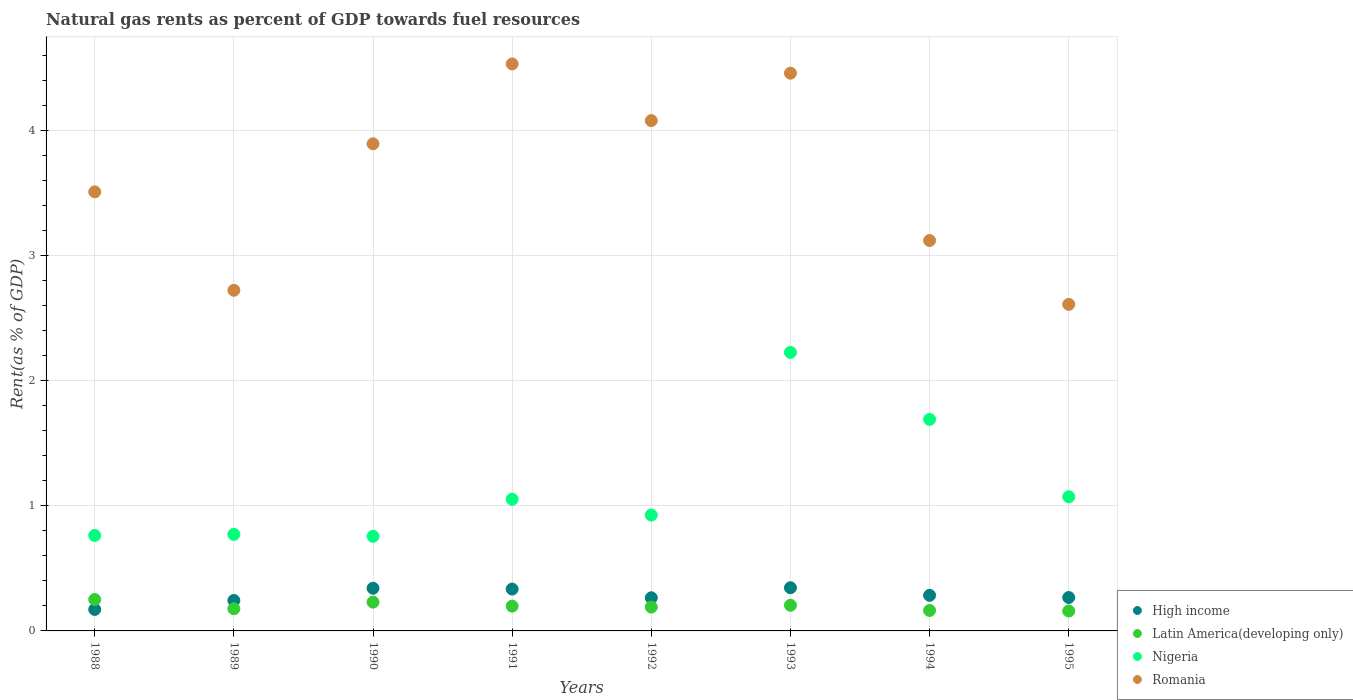How many different coloured dotlines are there?
Give a very brief answer. 4. Is the number of dotlines equal to the number of legend labels?
Ensure brevity in your answer.  Yes. What is the matural gas rent in Latin America(developing only) in 1992?
Offer a very short reply. 0.19. Across all years, what is the maximum matural gas rent in Nigeria?
Give a very brief answer. 2.23. Across all years, what is the minimum matural gas rent in Nigeria?
Your response must be concise. 0.76. In which year was the matural gas rent in Nigeria maximum?
Keep it short and to the point. 1993. In which year was the matural gas rent in Latin America(developing only) minimum?
Offer a terse response. 1995. What is the total matural gas rent in Romania in the graph?
Your answer should be compact. 28.93. What is the difference between the matural gas rent in Latin America(developing only) in 1990 and that in 1995?
Provide a short and direct response. 0.07. What is the difference between the matural gas rent in High income in 1991 and the matural gas rent in Latin America(developing only) in 1992?
Offer a very short reply. 0.14. What is the average matural gas rent in Romania per year?
Provide a short and direct response. 3.62. In the year 1990, what is the difference between the matural gas rent in Latin America(developing only) and matural gas rent in Nigeria?
Offer a terse response. -0.53. In how many years, is the matural gas rent in High income greater than 2 %?
Ensure brevity in your answer.  0. What is the ratio of the matural gas rent in Latin America(developing only) in 1991 to that in 1992?
Ensure brevity in your answer.  1.04. What is the difference between the highest and the second highest matural gas rent in Latin America(developing only)?
Offer a terse response. 0.02. What is the difference between the highest and the lowest matural gas rent in Nigeria?
Provide a short and direct response. 1.47. In how many years, is the matural gas rent in Latin America(developing only) greater than the average matural gas rent in Latin America(developing only) taken over all years?
Ensure brevity in your answer.  4. Is it the case that in every year, the sum of the matural gas rent in Latin America(developing only) and matural gas rent in Nigeria  is greater than the sum of matural gas rent in Romania and matural gas rent in High income?
Offer a very short reply. No. Is it the case that in every year, the sum of the matural gas rent in High income and matural gas rent in Nigeria  is greater than the matural gas rent in Romania?
Give a very brief answer. No. Does the matural gas rent in Romania monotonically increase over the years?
Make the answer very short. No. Is the matural gas rent in Nigeria strictly greater than the matural gas rent in High income over the years?
Provide a succinct answer. Yes. How many years are there in the graph?
Your answer should be compact. 8. What is the difference between two consecutive major ticks on the Y-axis?
Offer a very short reply. 1. Where does the legend appear in the graph?
Ensure brevity in your answer.  Bottom right. How many legend labels are there?
Your answer should be very brief. 4. What is the title of the graph?
Provide a succinct answer. Natural gas rents as percent of GDP towards fuel resources. What is the label or title of the X-axis?
Your answer should be compact. Years. What is the label or title of the Y-axis?
Provide a short and direct response. Rent(as % of GDP). What is the Rent(as % of GDP) of High income in 1988?
Ensure brevity in your answer.  0.17. What is the Rent(as % of GDP) of Latin America(developing only) in 1988?
Provide a short and direct response. 0.25. What is the Rent(as % of GDP) of Nigeria in 1988?
Give a very brief answer. 0.76. What is the Rent(as % of GDP) in Romania in 1988?
Ensure brevity in your answer.  3.51. What is the Rent(as % of GDP) in High income in 1989?
Offer a very short reply. 0.24. What is the Rent(as % of GDP) in Latin America(developing only) in 1989?
Offer a very short reply. 0.18. What is the Rent(as % of GDP) of Nigeria in 1989?
Make the answer very short. 0.77. What is the Rent(as % of GDP) of Romania in 1989?
Make the answer very short. 2.72. What is the Rent(as % of GDP) of High income in 1990?
Give a very brief answer. 0.34. What is the Rent(as % of GDP) in Latin America(developing only) in 1990?
Offer a very short reply. 0.23. What is the Rent(as % of GDP) of Nigeria in 1990?
Offer a terse response. 0.76. What is the Rent(as % of GDP) in Romania in 1990?
Give a very brief answer. 3.89. What is the Rent(as % of GDP) of High income in 1991?
Offer a terse response. 0.33. What is the Rent(as % of GDP) of Latin America(developing only) in 1991?
Your answer should be very brief. 0.2. What is the Rent(as % of GDP) in Nigeria in 1991?
Your answer should be very brief. 1.05. What is the Rent(as % of GDP) of Romania in 1991?
Your response must be concise. 4.53. What is the Rent(as % of GDP) of High income in 1992?
Offer a terse response. 0.26. What is the Rent(as % of GDP) of Latin America(developing only) in 1992?
Offer a terse response. 0.19. What is the Rent(as % of GDP) of Nigeria in 1992?
Your answer should be compact. 0.93. What is the Rent(as % of GDP) of Romania in 1992?
Your response must be concise. 4.08. What is the Rent(as % of GDP) of High income in 1993?
Provide a succinct answer. 0.35. What is the Rent(as % of GDP) of Latin America(developing only) in 1993?
Offer a very short reply. 0.21. What is the Rent(as % of GDP) of Nigeria in 1993?
Your answer should be very brief. 2.23. What is the Rent(as % of GDP) of Romania in 1993?
Your response must be concise. 4.46. What is the Rent(as % of GDP) in High income in 1994?
Give a very brief answer. 0.28. What is the Rent(as % of GDP) in Latin America(developing only) in 1994?
Ensure brevity in your answer.  0.16. What is the Rent(as % of GDP) in Nigeria in 1994?
Provide a short and direct response. 1.69. What is the Rent(as % of GDP) in Romania in 1994?
Ensure brevity in your answer.  3.12. What is the Rent(as % of GDP) of High income in 1995?
Your answer should be compact. 0.27. What is the Rent(as % of GDP) of Latin America(developing only) in 1995?
Give a very brief answer. 0.16. What is the Rent(as % of GDP) in Nigeria in 1995?
Provide a short and direct response. 1.07. What is the Rent(as % of GDP) of Romania in 1995?
Offer a very short reply. 2.61. Across all years, what is the maximum Rent(as % of GDP) in High income?
Give a very brief answer. 0.35. Across all years, what is the maximum Rent(as % of GDP) in Latin America(developing only)?
Your answer should be compact. 0.25. Across all years, what is the maximum Rent(as % of GDP) in Nigeria?
Make the answer very short. 2.23. Across all years, what is the maximum Rent(as % of GDP) in Romania?
Your answer should be compact. 4.53. Across all years, what is the minimum Rent(as % of GDP) of High income?
Offer a very short reply. 0.17. Across all years, what is the minimum Rent(as % of GDP) in Latin America(developing only)?
Ensure brevity in your answer.  0.16. Across all years, what is the minimum Rent(as % of GDP) in Nigeria?
Your response must be concise. 0.76. Across all years, what is the minimum Rent(as % of GDP) of Romania?
Give a very brief answer. 2.61. What is the total Rent(as % of GDP) in High income in the graph?
Make the answer very short. 2.25. What is the total Rent(as % of GDP) in Latin America(developing only) in the graph?
Offer a very short reply. 1.58. What is the total Rent(as % of GDP) in Nigeria in the graph?
Offer a very short reply. 9.26. What is the total Rent(as % of GDP) of Romania in the graph?
Your response must be concise. 28.93. What is the difference between the Rent(as % of GDP) of High income in 1988 and that in 1989?
Provide a succinct answer. -0.07. What is the difference between the Rent(as % of GDP) of Latin America(developing only) in 1988 and that in 1989?
Make the answer very short. 0.07. What is the difference between the Rent(as % of GDP) in Nigeria in 1988 and that in 1989?
Your response must be concise. -0.01. What is the difference between the Rent(as % of GDP) in Romania in 1988 and that in 1989?
Give a very brief answer. 0.79. What is the difference between the Rent(as % of GDP) of High income in 1988 and that in 1990?
Your response must be concise. -0.17. What is the difference between the Rent(as % of GDP) in Latin America(developing only) in 1988 and that in 1990?
Your answer should be compact. 0.02. What is the difference between the Rent(as % of GDP) of Nigeria in 1988 and that in 1990?
Your response must be concise. 0.01. What is the difference between the Rent(as % of GDP) of Romania in 1988 and that in 1990?
Ensure brevity in your answer.  -0.38. What is the difference between the Rent(as % of GDP) of High income in 1988 and that in 1991?
Your response must be concise. -0.16. What is the difference between the Rent(as % of GDP) in Latin America(developing only) in 1988 and that in 1991?
Ensure brevity in your answer.  0.05. What is the difference between the Rent(as % of GDP) in Nigeria in 1988 and that in 1991?
Your answer should be compact. -0.29. What is the difference between the Rent(as % of GDP) in Romania in 1988 and that in 1991?
Provide a succinct answer. -1.02. What is the difference between the Rent(as % of GDP) of High income in 1988 and that in 1992?
Make the answer very short. -0.09. What is the difference between the Rent(as % of GDP) in Latin America(developing only) in 1988 and that in 1992?
Your answer should be very brief. 0.06. What is the difference between the Rent(as % of GDP) in Nigeria in 1988 and that in 1992?
Your answer should be compact. -0.16. What is the difference between the Rent(as % of GDP) in Romania in 1988 and that in 1992?
Keep it short and to the point. -0.57. What is the difference between the Rent(as % of GDP) of High income in 1988 and that in 1993?
Your answer should be compact. -0.17. What is the difference between the Rent(as % of GDP) in Latin America(developing only) in 1988 and that in 1993?
Keep it short and to the point. 0.05. What is the difference between the Rent(as % of GDP) in Nigeria in 1988 and that in 1993?
Keep it short and to the point. -1.46. What is the difference between the Rent(as % of GDP) of Romania in 1988 and that in 1993?
Ensure brevity in your answer.  -0.95. What is the difference between the Rent(as % of GDP) in High income in 1988 and that in 1994?
Provide a succinct answer. -0.11. What is the difference between the Rent(as % of GDP) in Latin America(developing only) in 1988 and that in 1994?
Provide a short and direct response. 0.09. What is the difference between the Rent(as % of GDP) in Nigeria in 1988 and that in 1994?
Offer a very short reply. -0.93. What is the difference between the Rent(as % of GDP) in Romania in 1988 and that in 1994?
Provide a short and direct response. 0.39. What is the difference between the Rent(as % of GDP) of High income in 1988 and that in 1995?
Offer a very short reply. -0.1. What is the difference between the Rent(as % of GDP) in Latin America(developing only) in 1988 and that in 1995?
Provide a short and direct response. 0.09. What is the difference between the Rent(as % of GDP) of Nigeria in 1988 and that in 1995?
Your answer should be compact. -0.31. What is the difference between the Rent(as % of GDP) of Romania in 1988 and that in 1995?
Make the answer very short. 0.9. What is the difference between the Rent(as % of GDP) in High income in 1989 and that in 1990?
Make the answer very short. -0.1. What is the difference between the Rent(as % of GDP) in Latin America(developing only) in 1989 and that in 1990?
Offer a terse response. -0.05. What is the difference between the Rent(as % of GDP) in Nigeria in 1989 and that in 1990?
Offer a terse response. 0.02. What is the difference between the Rent(as % of GDP) in Romania in 1989 and that in 1990?
Keep it short and to the point. -1.17. What is the difference between the Rent(as % of GDP) in High income in 1989 and that in 1991?
Ensure brevity in your answer.  -0.09. What is the difference between the Rent(as % of GDP) of Latin America(developing only) in 1989 and that in 1991?
Ensure brevity in your answer.  -0.02. What is the difference between the Rent(as % of GDP) of Nigeria in 1989 and that in 1991?
Your answer should be very brief. -0.28. What is the difference between the Rent(as % of GDP) in Romania in 1989 and that in 1991?
Your response must be concise. -1.81. What is the difference between the Rent(as % of GDP) in High income in 1989 and that in 1992?
Offer a terse response. -0.02. What is the difference between the Rent(as % of GDP) of Latin America(developing only) in 1989 and that in 1992?
Provide a short and direct response. -0.01. What is the difference between the Rent(as % of GDP) in Nigeria in 1989 and that in 1992?
Make the answer very short. -0.15. What is the difference between the Rent(as % of GDP) in Romania in 1989 and that in 1992?
Offer a terse response. -1.36. What is the difference between the Rent(as % of GDP) in High income in 1989 and that in 1993?
Your response must be concise. -0.1. What is the difference between the Rent(as % of GDP) of Latin America(developing only) in 1989 and that in 1993?
Your answer should be compact. -0.03. What is the difference between the Rent(as % of GDP) in Nigeria in 1989 and that in 1993?
Keep it short and to the point. -1.45. What is the difference between the Rent(as % of GDP) of Romania in 1989 and that in 1993?
Keep it short and to the point. -1.74. What is the difference between the Rent(as % of GDP) of High income in 1989 and that in 1994?
Provide a short and direct response. -0.04. What is the difference between the Rent(as % of GDP) of Latin America(developing only) in 1989 and that in 1994?
Provide a short and direct response. 0.01. What is the difference between the Rent(as % of GDP) in Nigeria in 1989 and that in 1994?
Ensure brevity in your answer.  -0.92. What is the difference between the Rent(as % of GDP) in Romania in 1989 and that in 1994?
Provide a short and direct response. -0.4. What is the difference between the Rent(as % of GDP) of High income in 1989 and that in 1995?
Make the answer very short. -0.02. What is the difference between the Rent(as % of GDP) in Latin America(developing only) in 1989 and that in 1995?
Your response must be concise. 0.02. What is the difference between the Rent(as % of GDP) in Nigeria in 1989 and that in 1995?
Keep it short and to the point. -0.3. What is the difference between the Rent(as % of GDP) of Romania in 1989 and that in 1995?
Make the answer very short. 0.11. What is the difference between the Rent(as % of GDP) in High income in 1990 and that in 1991?
Your answer should be very brief. 0.01. What is the difference between the Rent(as % of GDP) in Latin America(developing only) in 1990 and that in 1991?
Make the answer very short. 0.03. What is the difference between the Rent(as % of GDP) in Nigeria in 1990 and that in 1991?
Offer a very short reply. -0.3. What is the difference between the Rent(as % of GDP) in Romania in 1990 and that in 1991?
Make the answer very short. -0.64. What is the difference between the Rent(as % of GDP) in High income in 1990 and that in 1992?
Offer a terse response. 0.08. What is the difference between the Rent(as % of GDP) in Latin America(developing only) in 1990 and that in 1992?
Make the answer very short. 0.04. What is the difference between the Rent(as % of GDP) in Nigeria in 1990 and that in 1992?
Your answer should be very brief. -0.17. What is the difference between the Rent(as % of GDP) of Romania in 1990 and that in 1992?
Give a very brief answer. -0.19. What is the difference between the Rent(as % of GDP) of High income in 1990 and that in 1993?
Provide a succinct answer. -0. What is the difference between the Rent(as % of GDP) of Latin America(developing only) in 1990 and that in 1993?
Offer a terse response. 0.03. What is the difference between the Rent(as % of GDP) of Nigeria in 1990 and that in 1993?
Make the answer very short. -1.47. What is the difference between the Rent(as % of GDP) of Romania in 1990 and that in 1993?
Provide a short and direct response. -0.56. What is the difference between the Rent(as % of GDP) in High income in 1990 and that in 1994?
Your response must be concise. 0.06. What is the difference between the Rent(as % of GDP) of Latin America(developing only) in 1990 and that in 1994?
Your response must be concise. 0.07. What is the difference between the Rent(as % of GDP) in Nigeria in 1990 and that in 1994?
Give a very brief answer. -0.93. What is the difference between the Rent(as % of GDP) of Romania in 1990 and that in 1994?
Your answer should be very brief. 0.77. What is the difference between the Rent(as % of GDP) of High income in 1990 and that in 1995?
Offer a very short reply. 0.07. What is the difference between the Rent(as % of GDP) of Latin America(developing only) in 1990 and that in 1995?
Provide a succinct answer. 0.07. What is the difference between the Rent(as % of GDP) in Nigeria in 1990 and that in 1995?
Your response must be concise. -0.32. What is the difference between the Rent(as % of GDP) of Romania in 1990 and that in 1995?
Keep it short and to the point. 1.28. What is the difference between the Rent(as % of GDP) in High income in 1991 and that in 1992?
Offer a very short reply. 0.07. What is the difference between the Rent(as % of GDP) of Latin America(developing only) in 1991 and that in 1992?
Offer a terse response. 0.01. What is the difference between the Rent(as % of GDP) in Nigeria in 1991 and that in 1992?
Provide a succinct answer. 0.13. What is the difference between the Rent(as % of GDP) in Romania in 1991 and that in 1992?
Your response must be concise. 0.45. What is the difference between the Rent(as % of GDP) in High income in 1991 and that in 1993?
Ensure brevity in your answer.  -0.01. What is the difference between the Rent(as % of GDP) of Latin America(developing only) in 1991 and that in 1993?
Your answer should be very brief. -0.01. What is the difference between the Rent(as % of GDP) in Nigeria in 1991 and that in 1993?
Give a very brief answer. -1.17. What is the difference between the Rent(as % of GDP) in Romania in 1991 and that in 1993?
Keep it short and to the point. 0.07. What is the difference between the Rent(as % of GDP) in High income in 1991 and that in 1994?
Keep it short and to the point. 0.05. What is the difference between the Rent(as % of GDP) in Latin America(developing only) in 1991 and that in 1994?
Provide a succinct answer. 0.03. What is the difference between the Rent(as % of GDP) of Nigeria in 1991 and that in 1994?
Provide a succinct answer. -0.64. What is the difference between the Rent(as % of GDP) of Romania in 1991 and that in 1994?
Provide a succinct answer. 1.41. What is the difference between the Rent(as % of GDP) of High income in 1991 and that in 1995?
Offer a very short reply. 0.07. What is the difference between the Rent(as % of GDP) of Latin America(developing only) in 1991 and that in 1995?
Keep it short and to the point. 0.04. What is the difference between the Rent(as % of GDP) of Nigeria in 1991 and that in 1995?
Give a very brief answer. -0.02. What is the difference between the Rent(as % of GDP) of Romania in 1991 and that in 1995?
Keep it short and to the point. 1.92. What is the difference between the Rent(as % of GDP) of High income in 1992 and that in 1993?
Keep it short and to the point. -0.08. What is the difference between the Rent(as % of GDP) of Latin America(developing only) in 1992 and that in 1993?
Your answer should be compact. -0.01. What is the difference between the Rent(as % of GDP) in Nigeria in 1992 and that in 1993?
Give a very brief answer. -1.3. What is the difference between the Rent(as % of GDP) of Romania in 1992 and that in 1993?
Ensure brevity in your answer.  -0.38. What is the difference between the Rent(as % of GDP) in High income in 1992 and that in 1994?
Provide a short and direct response. -0.02. What is the difference between the Rent(as % of GDP) in Latin America(developing only) in 1992 and that in 1994?
Your answer should be very brief. 0.03. What is the difference between the Rent(as % of GDP) of Nigeria in 1992 and that in 1994?
Give a very brief answer. -0.77. What is the difference between the Rent(as % of GDP) in High income in 1992 and that in 1995?
Offer a terse response. -0. What is the difference between the Rent(as % of GDP) of Latin America(developing only) in 1992 and that in 1995?
Your answer should be compact. 0.03. What is the difference between the Rent(as % of GDP) of Nigeria in 1992 and that in 1995?
Provide a short and direct response. -0.15. What is the difference between the Rent(as % of GDP) in Romania in 1992 and that in 1995?
Offer a terse response. 1.47. What is the difference between the Rent(as % of GDP) in High income in 1993 and that in 1994?
Provide a short and direct response. 0.06. What is the difference between the Rent(as % of GDP) in Latin America(developing only) in 1993 and that in 1994?
Give a very brief answer. 0.04. What is the difference between the Rent(as % of GDP) of Nigeria in 1993 and that in 1994?
Give a very brief answer. 0.54. What is the difference between the Rent(as % of GDP) of Romania in 1993 and that in 1994?
Ensure brevity in your answer.  1.34. What is the difference between the Rent(as % of GDP) in High income in 1993 and that in 1995?
Provide a succinct answer. 0.08. What is the difference between the Rent(as % of GDP) in Latin America(developing only) in 1993 and that in 1995?
Your answer should be very brief. 0.05. What is the difference between the Rent(as % of GDP) of Nigeria in 1993 and that in 1995?
Keep it short and to the point. 1.15. What is the difference between the Rent(as % of GDP) of Romania in 1993 and that in 1995?
Ensure brevity in your answer.  1.85. What is the difference between the Rent(as % of GDP) of High income in 1994 and that in 1995?
Provide a short and direct response. 0.02. What is the difference between the Rent(as % of GDP) of Latin America(developing only) in 1994 and that in 1995?
Your answer should be compact. 0. What is the difference between the Rent(as % of GDP) in Nigeria in 1994 and that in 1995?
Make the answer very short. 0.62. What is the difference between the Rent(as % of GDP) of Romania in 1994 and that in 1995?
Offer a very short reply. 0.51. What is the difference between the Rent(as % of GDP) of High income in 1988 and the Rent(as % of GDP) of Latin America(developing only) in 1989?
Your answer should be compact. -0.01. What is the difference between the Rent(as % of GDP) of High income in 1988 and the Rent(as % of GDP) of Nigeria in 1989?
Make the answer very short. -0.6. What is the difference between the Rent(as % of GDP) of High income in 1988 and the Rent(as % of GDP) of Romania in 1989?
Give a very brief answer. -2.55. What is the difference between the Rent(as % of GDP) of Latin America(developing only) in 1988 and the Rent(as % of GDP) of Nigeria in 1989?
Provide a succinct answer. -0.52. What is the difference between the Rent(as % of GDP) of Latin America(developing only) in 1988 and the Rent(as % of GDP) of Romania in 1989?
Your answer should be compact. -2.47. What is the difference between the Rent(as % of GDP) in Nigeria in 1988 and the Rent(as % of GDP) in Romania in 1989?
Give a very brief answer. -1.96. What is the difference between the Rent(as % of GDP) of High income in 1988 and the Rent(as % of GDP) of Latin America(developing only) in 1990?
Ensure brevity in your answer.  -0.06. What is the difference between the Rent(as % of GDP) of High income in 1988 and the Rent(as % of GDP) of Nigeria in 1990?
Offer a terse response. -0.58. What is the difference between the Rent(as % of GDP) in High income in 1988 and the Rent(as % of GDP) in Romania in 1990?
Make the answer very short. -3.72. What is the difference between the Rent(as % of GDP) in Latin America(developing only) in 1988 and the Rent(as % of GDP) in Nigeria in 1990?
Give a very brief answer. -0.51. What is the difference between the Rent(as % of GDP) in Latin America(developing only) in 1988 and the Rent(as % of GDP) in Romania in 1990?
Your answer should be compact. -3.64. What is the difference between the Rent(as % of GDP) in Nigeria in 1988 and the Rent(as % of GDP) in Romania in 1990?
Offer a very short reply. -3.13. What is the difference between the Rent(as % of GDP) in High income in 1988 and the Rent(as % of GDP) in Latin America(developing only) in 1991?
Make the answer very short. -0.03. What is the difference between the Rent(as % of GDP) in High income in 1988 and the Rent(as % of GDP) in Nigeria in 1991?
Give a very brief answer. -0.88. What is the difference between the Rent(as % of GDP) in High income in 1988 and the Rent(as % of GDP) in Romania in 1991?
Your answer should be compact. -4.36. What is the difference between the Rent(as % of GDP) of Latin America(developing only) in 1988 and the Rent(as % of GDP) of Nigeria in 1991?
Make the answer very short. -0.8. What is the difference between the Rent(as % of GDP) in Latin America(developing only) in 1988 and the Rent(as % of GDP) in Romania in 1991?
Give a very brief answer. -4.28. What is the difference between the Rent(as % of GDP) in Nigeria in 1988 and the Rent(as % of GDP) in Romania in 1991?
Your response must be concise. -3.77. What is the difference between the Rent(as % of GDP) of High income in 1988 and the Rent(as % of GDP) of Latin America(developing only) in 1992?
Your answer should be compact. -0.02. What is the difference between the Rent(as % of GDP) in High income in 1988 and the Rent(as % of GDP) in Nigeria in 1992?
Offer a very short reply. -0.75. What is the difference between the Rent(as % of GDP) in High income in 1988 and the Rent(as % of GDP) in Romania in 1992?
Your response must be concise. -3.91. What is the difference between the Rent(as % of GDP) of Latin America(developing only) in 1988 and the Rent(as % of GDP) of Nigeria in 1992?
Provide a short and direct response. -0.68. What is the difference between the Rent(as % of GDP) in Latin America(developing only) in 1988 and the Rent(as % of GDP) in Romania in 1992?
Give a very brief answer. -3.83. What is the difference between the Rent(as % of GDP) in Nigeria in 1988 and the Rent(as % of GDP) in Romania in 1992?
Offer a very short reply. -3.32. What is the difference between the Rent(as % of GDP) in High income in 1988 and the Rent(as % of GDP) in Latin America(developing only) in 1993?
Keep it short and to the point. -0.03. What is the difference between the Rent(as % of GDP) in High income in 1988 and the Rent(as % of GDP) in Nigeria in 1993?
Your answer should be compact. -2.05. What is the difference between the Rent(as % of GDP) of High income in 1988 and the Rent(as % of GDP) of Romania in 1993?
Provide a short and direct response. -4.29. What is the difference between the Rent(as % of GDP) of Latin America(developing only) in 1988 and the Rent(as % of GDP) of Nigeria in 1993?
Offer a very short reply. -1.98. What is the difference between the Rent(as % of GDP) in Latin America(developing only) in 1988 and the Rent(as % of GDP) in Romania in 1993?
Provide a short and direct response. -4.21. What is the difference between the Rent(as % of GDP) in Nigeria in 1988 and the Rent(as % of GDP) in Romania in 1993?
Give a very brief answer. -3.7. What is the difference between the Rent(as % of GDP) in High income in 1988 and the Rent(as % of GDP) in Latin America(developing only) in 1994?
Keep it short and to the point. 0.01. What is the difference between the Rent(as % of GDP) of High income in 1988 and the Rent(as % of GDP) of Nigeria in 1994?
Ensure brevity in your answer.  -1.52. What is the difference between the Rent(as % of GDP) in High income in 1988 and the Rent(as % of GDP) in Romania in 1994?
Your answer should be very brief. -2.95. What is the difference between the Rent(as % of GDP) in Latin America(developing only) in 1988 and the Rent(as % of GDP) in Nigeria in 1994?
Offer a terse response. -1.44. What is the difference between the Rent(as % of GDP) in Latin America(developing only) in 1988 and the Rent(as % of GDP) in Romania in 1994?
Ensure brevity in your answer.  -2.87. What is the difference between the Rent(as % of GDP) of Nigeria in 1988 and the Rent(as % of GDP) of Romania in 1994?
Offer a very short reply. -2.36. What is the difference between the Rent(as % of GDP) of High income in 1988 and the Rent(as % of GDP) of Latin America(developing only) in 1995?
Give a very brief answer. 0.01. What is the difference between the Rent(as % of GDP) of High income in 1988 and the Rent(as % of GDP) of Nigeria in 1995?
Make the answer very short. -0.9. What is the difference between the Rent(as % of GDP) in High income in 1988 and the Rent(as % of GDP) in Romania in 1995?
Your answer should be compact. -2.44. What is the difference between the Rent(as % of GDP) in Latin America(developing only) in 1988 and the Rent(as % of GDP) in Nigeria in 1995?
Offer a very short reply. -0.82. What is the difference between the Rent(as % of GDP) in Latin America(developing only) in 1988 and the Rent(as % of GDP) in Romania in 1995?
Your answer should be very brief. -2.36. What is the difference between the Rent(as % of GDP) of Nigeria in 1988 and the Rent(as % of GDP) of Romania in 1995?
Your response must be concise. -1.85. What is the difference between the Rent(as % of GDP) of High income in 1989 and the Rent(as % of GDP) of Latin America(developing only) in 1990?
Make the answer very short. 0.01. What is the difference between the Rent(as % of GDP) of High income in 1989 and the Rent(as % of GDP) of Nigeria in 1990?
Offer a terse response. -0.51. What is the difference between the Rent(as % of GDP) of High income in 1989 and the Rent(as % of GDP) of Romania in 1990?
Ensure brevity in your answer.  -3.65. What is the difference between the Rent(as % of GDP) in Latin America(developing only) in 1989 and the Rent(as % of GDP) in Nigeria in 1990?
Offer a terse response. -0.58. What is the difference between the Rent(as % of GDP) in Latin America(developing only) in 1989 and the Rent(as % of GDP) in Romania in 1990?
Provide a short and direct response. -3.72. What is the difference between the Rent(as % of GDP) in Nigeria in 1989 and the Rent(as % of GDP) in Romania in 1990?
Make the answer very short. -3.12. What is the difference between the Rent(as % of GDP) in High income in 1989 and the Rent(as % of GDP) in Latin America(developing only) in 1991?
Make the answer very short. 0.05. What is the difference between the Rent(as % of GDP) of High income in 1989 and the Rent(as % of GDP) of Nigeria in 1991?
Provide a short and direct response. -0.81. What is the difference between the Rent(as % of GDP) in High income in 1989 and the Rent(as % of GDP) in Romania in 1991?
Ensure brevity in your answer.  -4.29. What is the difference between the Rent(as % of GDP) in Latin America(developing only) in 1989 and the Rent(as % of GDP) in Nigeria in 1991?
Keep it short and to the point. -0.88. What is the difference between the Rent(as % of GDP) in Latin America(developing only) in 1989 and the Rent(as % of GDP) in Romania in 1991?
Your answer should be compact. -4.36. What is the difference between the Rent(as % of GDP) of Nigeria in 1989 and the Rent(as % of GDP) of Romania in 1991?
Ensure brevity in your answer.  -3.76. What is the difference between the Rent(as % of GDP) of High income in 1989 and the Rent(as % of GDP) of Latin America(developing only) in 1992?
Offer a very short reply. 0.05. What is the difference between the Rent(as % of GDP) in High income in 1989 and the Rent(as % of GDP) in Nigeria in 1992?
Make the answer very short. -0.68. What is the difference between the Rent(as % of GDP) of High income in 1989 and the Rent(as % of GDP) of Romania in 1992?
Keep it short and to the point. -3.84. What is the difference between the Rent(as % of GDP) in Latin America(developing only) in 1989 and the Rent(as % of GDP) in Nigeria in 1992?
Your answer should be very brief. -0.75. What is the difference between the Rent(as % of GDP) of Latin America(developing only) in 1989 and the Rent(as % of GDP) of Romania in 1992?
Offer a very short reply. -3.9. What is the difference between the Rent(as % of GDP) of Nigeria in 1989 and the Rent(as % of GDP) of Romania in 1992?
Make the answer very short. -3.31. What is the difference between the Rent(as % of GDP) in High income in 1989 and the Rent(as % of GDP) in Latin America(developing only) in 1993?
Make the answer very short. 0.04. What is the difference between the Rent(as % of GDP) of High income in 1989 and the Rent(as % of GDP) of Nigeria in 1993?
Your answer should be compact. -1.98. What is the difference between the Rent(as % of GDP) of High income in 1989 and the Rent(as % of GDP) of Romania in 1993?
Offer a terse response. -4.22. What is the difference between the Rent(as % of GDP) of Latin America(developing only) in 1989 and the Rent(as % of GDP) of Nigeria in 1993?
Provide a short and direct response. -2.05. What is the difference between the Rent(as % of GDP) of Latin America(developing only) in 1989 and the Rent(as % of GDP) of Romania in 1993?
Your response must be concise. -4.28. What is the difference between the Rent(as % of GDP) in Nigeria in 1989 and the Rent(as % of GDP) in Romania in 1993?
Ensure brevity in your answer.  -3.69. What is the difference between the Rent(as % of GDP) of High income in 1989 and the Rent(as % of GDP) of Latin America(developing only) in 1994?
Provide a short and direct response. 0.08. What is the difference between the Rent(as % of GDP) of High income in 1989 and the Rent(as % of GDP) of Nigeria in 1994?
Ensure brevity in your answer.  -1.45. What is the difference between the Rent(as % of GDP) of High income in 1989 and the Rent(as % of GDP) of Romania in 1994?
Make the answer very short. -2.88. What is the difference between the Rent(as % of GDP) in Latin America(developing only) in 1989 and the Rent(as % of GDP) in Nigeria in 1994?
Keep it short and to the point. -1.51. What is the difference between the Rent(as % of GDP) of Latin America(developing only) in 1989 and the Rent(as % of GDP) of Romania in 1994?
Make the answer very short. -2.94. What is the difference between the Rent(as % of GDP) of Nigeria in 1989 and the Rent(as % of GDP) of Romania in 1994?
Offer a terse response. -2.35. What is the difference between the Rent(as % of GDP) in High income in 1989 and the Rent(as % of GDP) in Latin America(developing only) in 1995?
Your answer should be very brief. 0.08. What is the difference between the Rent(as % of GDP) of High income in 1989 and the Rent(as % of GDP) of Nigeria in 1995?
Your answer should be compact. -0.83. What is the difference between the Rent(as % of GDP) of High income in 1989 and the Rent(as % of GDP) of Romania in 1995?
Your response must be concise. -2.37. What is the difference between the Rent(as % of GDP) in Latin America(developing only) in 1989 and the Rent(as % of GDP) in Nigeria in 1995?
Your answer should be compact. -0.9. What is the difference between the Rent(as % of GDP) of Latin America(developing only) in 1989 and the Rent(as % of GDP) of Romania in 1995?
Your answer should be very brief. -2.43. What is the difference between the Rent(as % of GDP) in Nigeria in 1989 and the Rent(as % of GDP) in Romania in 1995?
Provide a short and direct response. -1.84. What is the difference between the Rent(as % of GDP) in High income in 1990 and the Rent(as % of GDP) in Latin America(developing only) in 1991?
Give a very brief answer. 0.14. What is the difference between the Rent(as % of GDP) in High income in 1990 and the Rent(as % of GDP) in Nigeria in 1991?
Provide a succinct answer. -0.71. What is the difference between the Rent(as % of GDP) of High income in 1990 and the Rent(as % of GDP) of Romania in 1991?
Your answer should be compact. -4.19. What is the difference between the Rent(as % of GDP) of Latin America(developing only) in 1990 and the Rent(as % of GDP) of Nigeria in 1991?
Provide a succinct answer. -0.82. What is the difference between the Rent(as % of GDP) in Latin America(developing only) in 1990 and the Rent(as % of GDP) in Romania in 1991?
Your answer should be very brief. -4.3. What is the difference between the Rent(as % of GDP) of Nigeria in 1990 and the Rent(as % of GDP) of Romania in 1991?
Offer a very short reply. -3.78. What is the difference between the Rent(as % of GDP) in High income in 1990 and the Rent(as % of GDP) in Latin America(developing only) in 1992?
Keep it short and to the point. 0.15. What is the difference between the Rent(as % of GDP) in High income in 1990 and the Rent(as % of GDP) in Nigeria in 1992?
Ensure brevity in your answer.  -0.58. What is the difference between the Rent(as % of GDP) of High income in 1990 and the Rent(as % of GDP) of Romania in 1992?
Offer a terse response. -3.74. What is the difference between the Rent(as % of GDP) in Latin America(developing only) in 1990 and the Rent(as % of GDP) in Nigeria in 1992?
Provide a succinct answer. -0.7. What is the difference between the Rent(as % of GDP) of Latin America(developing only) in 1990 and the Rent(as % of GDP) of Romania in 1992?
Your answer should be very brief. -3.85. What is the difference between the Rent(as % of GDP) of Nigeria in 1990 and the Rent(as % of GDP) of Romania in 1992?
Keep it short and to the point. -3.32. What is the difference between the Rent(as % of GDP) in High income in 1990 and the Rent(as % of GDP) in Latin America(developing only) in 1993?
Provide a short and direct response. 0.14. What is the difference between the Rent(as % of GDP) in High income in 1990 and the Rent(as % of GDP) in Nigeria in 1993?
Make the answer very short. -1.89. What is the difference between the Rent(as % of GDP) in High income in 1990 and the Rent(as % of GDP) in Romania in 1993?
Offer a terse response. -4.12. What is the difference between the Rent(as % of GDP) in Latin America(developing only) in 1990 and the Rent(as % of GDP) in Nigeria in 1993?
Your response must be concise. -2. What is the difference between the Rent(as % of GDP) of Latin America(developing only) in 1990 and the Rent(as % of GDP) of Romania in 1993?
Provide a succinct answer. -4.23. What is the difference between the Rent(as % of GDP) in Nigeria in 1990 and the Rent(as % of GDP) in Romania in 1993?
Keep it short and to the point. -3.7. What is the difference between the Rent(as % of GDP) of High income in 1990 and the Rent(as % of GDP) of Latin America(developing only) in 1994?
Ensure brevity in your answer.  0.18. What is the difference between the Rent(as % of GDP) in High income in 1990 and the Rent(as % of GDP) in Nigeria in 1994?
Your response must be concise. -1.35. What is the difference between the Rent(as % of GDP) in High income in 1990 and the Rent(as % of GDP) in Romania in 1994?
Your answer should be very brief. -2.78. What is the difference between the Rent(as % of GDP) of Latin America(developing only) in 1990 and the Rent(as % of GDP) of Nigeria in 1994?
Offer a terse response. -1.46. What is the difference between the Rent(as % of GDP) of Latin America(developing only) in 1990 and the Rent(as % of GDP) of Romania in 1994?
Offer a very short reply. -2.89. What is the difference between the Rent(as % of GDP) of Nigeria in 1990 and the Rent(as % of GDP) of Romania in 1994?
Give a very brief answer. -2.36. What is the difference between the Rent(as % of GDP) in High income in 1990 and the Rent(as % of GDP) in Latin America(developing only) in 1995?
Give a very brief answer. 0.18. What is the difference between the Rent(as % of GDP) of High income in 1990 and the Rent(as % of GDP) of Nigeria in 1995?
Your answer should be very brief. -0.73. What is the difference between the Rent(as % of GDP) of High income in 1990 and the Rent(as % of GDP) of Romania in 1995?
Your answer should be compact. -2.27. What is the difference between the Rent(as % of GDP) in Latin America(developing only) in 1990 and the Rent(as % of GDP) in Nigeria in 1995?
Ensure brevity in your answer.  -0.84. What is the difference between the Rent(as % of GDP) of Latin America(developing only) in 1990 and the Rent(as % of GDP) of Romania in 1995?
Make the answer very short. -2.38. What is the difference between the Rent(as % of GDP) of Nigeria in 1990 and the Rent(as % of GDP) of Romania in 1995?
Give a very brief answer. -1.85. What is the difference between the Rent(as % of GDP) in High income in 1991 and the Rent(as % of GDP) in Latin America(developing only) in 1992?
Keep it short and to the point. 0.14. What is the difference between the Rent(as % of GDP) of High income in 1991 and the Rent(as % of GDP) of Nigeria in 1992?
Your answer should be compact. -0.59. What is the difference between the Rent(as % of GDP) in High income in 1991 and the Rent(as % of GDP) in Romania in 1992?
Your answer should be compact. -3.74. What is the difference between the Rent(as % of GDP) of Latin America(developing only) in 1991 and the Rent(as % of GDP) of Nigeria in 1992?
Your answer should be very brief. -0.73. What is the difference between the Rent(as % of GDP) in Latin America(developing only) in 1991 and the Rent(as % of GDP) in Romania in 1992?
Your response must be concise. -3.88. What is the difference between the Rent(as % of GDP) of Nigeria in 1991 and the Rent(as % of GDP) of Romania in 1992?
Ensure brevity in your answer.  -3.03. What is the difference between the Rent(as % of GDP) in High income in 1991 and the Rent(as % of GDP) in Latin America(developing only) in 1993?
Your response must be concise. 0.13. What is the difference between the Rent(as % of GDP) of High income in 1991 and the Rent(as % of GDP) of Nigeria in 1993?
Ensure brevity in your answer.  -1.89. What is the difference between the Rent(as % of GDP) of High income in 1991 and the Rent(as % of GDP) of Romania in 1993?
Keep it short and to the point. -4.12. What is the difference between the Rent(as % of GDP) in Latin America(developing only) in 1991 and the Rent(as % of GDP) in Nigeria in 1993?
Give a very brief answer. -2.03. What is the difference between the Rent(as % of GDP) of Latin America(developing only) in 1991 and the Rent(as % of GDP) of Romania in 1993?
Ensure brevity in your answer.  -4.26. What is the difference between the Rent(as % of GDP) in Nigeria in 1991 and the Rent(as % of GDP) in Romania in 1993?
Keep it short and to the point. -3.41. What is the difference between the Rent(as % of GDP) of High income in 1991 and the Rent(as % of GDP) of Latin America(developing only) in 1994?
Keep it short and to the point. 0.17. What is the difference between the Rent(as % of GDP) of High income in 1991 and the Rent(as % of GDP) of Nigeria in 1994?
Your answer should be very brief. -1.36. What is the difference between the Rent(as % of GDP) in High income in 1991 and the Rent(as % of GDP) in Romania in 1994?
Give a very brief answer. -2.79. What is the difference between the Rent(as % of GDP) in Latin America(developing only) in 1991 and the Rent(as % of GDP) in Nigeria in 1994?
Your answer should be compact. -1.49. What is the difference between the Rent(as % of GDP) in Latin America(developing only) in 1991 and the Rent(as % of GDP) in Romania in 1994?
Offer a very short reply. -2.92. What is the difference between the Rent(as % of GDP) in Nigeria in 1991 and the Rent(as % of GDP) in Romania in 1994?
Offer a terse response. -2.07. What is the difference between the Rent(as % of GDP) in High income in 1991 and the Rent(as % of GDP) in Latin America(developing only) in 1995?
Ensure brevity in your answer.  0.18. What is the difference between the Rent(as % of GDP) of High income in 1991 and the Rent(as % of GDP) of Nigeria in 1995?
Offer a very short reply. -0.74. What is the difference between the Rent(as % of GDP) of High income in 1991 and the Rent(as % of GDP) of Romania in 1995?
Give a very brief answer. -2.28. What is the difference between the Rent(as % of GDP) in Latin America(developing only) in 1991 and the Rent(as % of GDP) in Nigeria in 1995?
Make the answer very short. -0.87. What is the difference between the Rent(as % of GDP) of Latin America(developing only) in 1991 and the Rent(as % of GDP) of Romania in 1995?
Make the answer very short. -2.41. What is the difference between the Rent(as % of GDP) in Nigeria in 1991 and the Rent(as % of GDP) in Romania in 1995?
Offer a very short reply. -1.56. What is the difference between the Rent(as % of GDP) of High income in 1992 and the Rent(as % of GDP) of Latin America(developing only) in 1993?
Offer a very short reply. 0.06. What is the difference between the Rent(as % of GDP) in High income in 1992 and the Rent(as % of GDP) in Nigeria in 1993?
Offer a very short reply. -1.96. What is the difference between the Rent(as % of GDP) in High income in 1992 and the Rent(as % of GDP) in Romania in 1993?
Ensure brevity in your answer.  -4.19. What is the difference between the Rent(as % of GDP) of Latin America(developing only) in 1992 and the Rent(as % of GDP) of Nigeria in 1993?
Keep it short and to the point. -2.04. What is the difference between the Rent(as % of GDP) in Latin America(developing only) in 1992 and the Rent(as % of GDP) in Romania in 1993?
Ensure brevity in your answer.  -4.27. What is the difference between the Rent(as % of GDP) in Nigeria in 1992 and the Rent(as % of GDP) in Romania in 1993?
Your response must be concise. -3.53. What is the difference between the Rent(as % of GDP) in High income in 1992 and the Rent(as % of GDP) in Latin America(developing only) in 1994?
Your answer should be compact. 0.1. What is the difference between the Rent(as % of GDP) of High income in 1992 and the Rent(as % of GDP) of Nigeria in 1994?
Provide a succinct answer. -1.43. What is the difference between the Rent(as % of GDP) of High income in 1992 and the Rent(as % of GDP) of Romania in 1994?
Ensure brevity in your answer.  -2.86. What is the difference between the Rent(as % of GDP) of Latin America(developing only) in 1992 and the Rent(as % of GDP) of Nigeria in 1994?
Your answer should be very brief. -1.5. What is the difference between the Rent(as % of GDP) in Latin America(developing only) in 1992 and the Rent(as % of GDP) in Romania in 1994?
Offer a very short reply. -2.93. What is the difference between the Rent(as % of GDP) in Nigeria in 1992 and the Rent(as % of GDP) in Romania in 1994?
Your answer should be very brief. -2.2. What is the difference between the Rent(as % of GDP) of High income in 1992 and the Rent(as % of GDP) of Latin America(developing only) in 1995?
Your answer should be very brief. 0.11. What is the difference between the Rent(as % of GDP) in High income in 1992 and the Rent(as % of GDP) in Nigeria in 1995?
Make the answer very short. -0.81. What is the difference between the Rent(as % of GDP) of High income in 1992 and the Rent(as % of GDP) of Romania in 1995?
Offer a terse response. -2.35. What is the difference between the Rent(as % of GDP) of Latin America(developing only) in 1992 and the Rent(as % of GDP) of Nigeria in 1995?
Your response must be concise. -0.88. What is the difference between the Rent(as % of GDP) in Latin America(developing only) in 1992 and the Rent(as % of GDP) in Romania in 1995?
Give a very brief answer. -2.42. What is the difference between the Rent(as % of GDP) in Nigeria in 1992 and the Rent(as % of GDP) in Romania in 1995?
Provide a short and direct response. -1.68. What is the difference between the Rent(as % of GDP) of High income in 1993 and the Rent(as % of GDP) of Latin America(developing only) in 1994?
Provide a succinct answer. 0.18. What is the difference between the Rent(as % of GDP) of High income in 1993 and the Rent(as % of GDP) of Nigeria in 1994?
Offer a very short reply. -1.35. What is the difference between the Rent(as % of GDP) in High income in 1993 and the Rent(as % of GDP) in Romania in 1994?
Your answer should be compact. -2.78. What is the difference between the Rent(as % of GDP) of Latin America(developing only) in 1993 and the Rent(as % of GDP) of Nigeria in 1994?
Make the answer very short. -1.49. What is the difference between the Rent(as % of GDP) of Latin America(developing only) in 1993 and the Rent(as % of GDP) of Romania in 1994?
Make the answer very short. -2.92. What is the difference between the Rent(as % of GDP) in Nigeria in 1993 and the Rent(as % of GDP) in Romania in 1994?
Make the answer very short. -0.89. What is the difference between the Rent(as % of GDP) of High income in 1993 and the Rent(as % of GDP) of Latin America(developing only) in 1995?
Make the answer very short. 0.19. What is the difference between the Rent(as % of GDP) in High income in 1993 and the Rent(as % of GDP) in Nigeria in 1995?
Your response must be concise. -0.73. What is the difference between the Rent(as % of GDP) in High income in 1993 and the Rent(as % of GDP) in Romania in 1995?
Make the answer very short. -2.27. What is the difference between the Rent(as % of GDP) of Latin America(developing only) in 1993 and the Rent(as % of GDP) of Nigeria in 1995?
Give a very brief answer. -0.87. What is the difference between the Rent(as % of GDP) in Latin America(developing only) in 1993 and the Rent(as % of GDP) in Romania in 1995?
Your answer should be compact. -2.41. What is the difference between the Rent(as % of GDP) of Nigeria in 1993 and the Rent(as % of GDP) of Romania in 1995?
Ensure brevity in your answer.  -0.38. What is the difference between the Rent(as % of GDP) of High income in 1994 and the Rent(as % of GDP) of Latin America(developing only) in 1995?
Provide a succinct answer. 0.13. What is the difference between the Rent(as % of GDP) in High income in 1994 and the Rent(as % of GDP) in Nigeria in 1995?
Offer a very short reply. -0.79. What is the difference between the Rent(as % of GDP) of High income in 1994 and the Rent(as % of GDP) of Romania in 1995?
Ensure brevity in your answer.  -2.33. What is the difference between the Rent(as % of GDP) of Latin America(developing only) in 1994 and the Rent(as % of GDP) of Nigeria in 1995?
Provide a succinct answer. -0.91. What is the difference between the Rent(as % of GDP) of Latin America(developing only) in 1994 and the Rent(as % of GDP) of Romania in 1995?
Offer a very short reply. -2.45. What is the difference between the Rent(as % of GDP) in Nigeria in 1994 and the Rent(as % of GDP) in Romania in 1995?
Make the answer very short. -0.92. What is the average Rent(as % of GDP) in High income per year?
Keep it short and to the point. 0.28. What is the average Rent(as % of GDP) in Latin America(developing only) per year?
Ensure brevity in your answer.  0.2. What is the average Rent(as % of GDP) in Nigeria per year?
Provide a short and direct response. 1.16. What is the average Rent(as % of GDP) in Romania per year?
Provide a succinct answer. 3.62. In the year 1988, what is the difference between the Rent(as % of GDP) of High income and Rent(as % of GDP) of Latin America(developing only)?
Provide a succinct answer. -0.08. In the year 1988, what is the difference between the Rent(as % of GDP) of High income and Rent(as % of GDP) of Nigeria?
Give a very brief answer. -0.59. In the year 1988, what is the difference between the Rent(as % of GDP) of High income and Rent(as % of GDP) of Romania?
Provide a succinct answer. -3.34. In the year 1988, what is the difference between the Rent(as % of GDP) in Latin America(developing only) and Rent(as % of GDP) in Nigeria?
Your answer should be very brief. -0.51. In the year 1988, what is the difference between the Rent(as % of GDP) in Latin America(developing only) and Rent(as % of GDP) in Romania?
Make the answer very short. -3.26. In the year 1988, what is the difference between the Rent(as % of GDP) of Nigeria and Rent(as % of GDP) of Romania?
Offer a very short reply. -2.75. In the year 1989, what is the difference between the Rent(as % of GDP) of High income and Rent(as % of GDP) of Latin America(developing only)?
Offer a terse response. 0.07. In the year 1989, what is the difference between the Rent(as % of GDP) in High income and Rent(as % of GDP) in Nigeria?
Keep it short and to the point. -0.53. In the year 1989, what is the difference between the Rent(as % of GDP) in High income and Rent(as % of GDP) in Romania?
Provide a succinct answer. -2.48. In the year 1989, what is the difference between the Rent(as % of GDP) in Latin America(developing only) and Rent(as % of GDP) in Nigeria?
Make the answer very short. -0.59. In the year 1989, what is the difference between the Rent(as % of GDP) of Latin America(developing only) and Rent(as % of GDP) of Romania?
Keep it short and to the point. -2.55. In the year 1989, what is the difference between the Rent(as % of GDP) of Nigeria and Rent(as % of GDP) of Romania?
Your response must be concise. -1.95. In the year 1990, what is the difference between the Rent(as % of GDP) in High income and Rent(as % of GDP) in Latin America(developing only)?
Make the answer very short. 0.11. In the year 1990, what is the difference between the Rent(as % of GDP) in High income and Rent(as % of GDP) in Nigeria?
Keep it short and to the point. -0.42. In the year 1990, what is the difference between the Rent(as % of GDP) of High income and Rent(as % of GDP) of Romania?
Keep it short and to the point. -3.55. In the year 1990, what is the difference between the Rent(as % of GDP) of Latin America(developing only) and Rent(as % of GDP) of Nigeria?
Your response must be concise. -0.53. In the year 1990, what is the difference between the Rent(as % of GDP) in Latin America(developing only) and Rent(as % of GDP) in Romania?
Your response must be concise. -3.66. In the year 1990, what is the difference between the Rent(as % of GDP) in Nigeria and Rent(as % of GDP) in Romania?
Make the answer very short. -3.14. In the year 1991, what is the difference between the Rent(as % of GDP) in High income and Rent(as % of GDP) in Latin America(developing only)?
Provide a succinct answer. 0.14. In the year 1991, what is the difference between the Rent(as % of GDP) of High income and Rent(as % of GDP) of Nigeria?
Ensure brevity in your answer.  -0.72. In the year 1991, what is the difference between the Rent(as % of GDP) in High income and Rent(as % of GDP) in Romania?
Your answer should be very brief. -4.2. In the year 1991, what is the difference between the Rent(as % of GDP) of Latin America(developing only) and Rent(as % of GDP) of Nigeria?
Provide a short and direct response. -0.85. In the year 1991, what is the difference between the Rent(as % of GDP) in Latin America(developing only) and Rent(as % of GDP) in Romania?
Ensure brevity in your answer.  -4.33. In the year 1991, what is the difference between the Rent(as % of GDP) of Nigeria and Rent(as % of GDP) of Romania?
Offer a terse response. -3.48. In the year 1992, what is the difference between the Rent(as % of GDP) in High income and Rent(as % of GDP) in Latin America(developing only)?
Your answer should be compact. 0.07. In the year 1992, what is the difference between the Rent(as % of GDP) in High income and Rent(as % of GDP) in Nigeria?
Your response must be concise. -0.66. In the year 1992, what is the difference between the Rent(as % of GDP) of High income and Rent(as % of GDP) of Romania?
Provide a succinct answer. -3.81. In the year 1992, what is the difference between the Rent(as % of GDP) in Latin America(developing only) and Rent(as % of GDP) in Nigeria?
Give a very brief answer. -0.74. In the year 1992, what is the difference between the Rent(as % of GDP) of Latin America(developing only) and Rent(as % of GDP) of Romania?
Keep it short and to the point. -3.89. In the year 1992, what is the difference between the Rent(as % of GDP) of Nigeria and Rent(as % of GDP) of Romania?
Your response must be concise. -3.15. In the year 1993, what is the difference between the Rent(as % of GDP) of High income and Rent(as % of GDP) of Latin America(developing only)?
Provide a succinct answer. 0.14. In the year 1993, what is the difference between the Rent(as % of GDP) of High income and Rent(as % of GDP) of Nigeria?
Your answer should be compact. -1.88. In the year 1993, what is the difference between the Rent(as % of GDP) of High income and Rent(as % of GDP) of Romania?
Your answer should be very brief. -4.11. In the year 1993, what is the difference between the Rent(as % of GDP) of Latin America(developing only) and Rent(as % of GDP) of Nigeria?
Ensure brevity in your answer.  -2.02. In the year 1993, what is the difference between the Rent(as % of GDP) in Latin America(developing only) and Rent(as % of GDP) in Romania?
Your answer should be compact. -4.25. In the year 1993, what is the difference between the Rent(as % of GDP) in Nigeria and Rent(as % of GDP) in Romania?
Ensure brevity in your answer.  -2.23. In the year 1994, what is the difference between the Rent(as % of GDP) of High income and Rent(as % of GDP) of Latin America(developing only)?
Your answer should be compact. 0.12. In the year 1994, what is the difference between the Rent(as % of GDP) in High income and Rent(as % of GDP) in Nigeria?
Your answer should be compact. -1.41. In the year 1994, what is the difference between the Rent(as % of GDP) of High income and Rent(as % of GDP) of Romania?
Offer a very short reply. -2.84. In the year 1994, what is the difference between the Rent(as % of GDP) of Latin America(developing only) and Rent(as % of GDP) of Nigeria?
Provide a short and direct response. -1.53. In the year 1994, what is the difference between the Rent(as % of GDP) in Latin America(developing only) and Rent(as % of GDP) in Romania?
Offer a terse response. -2.96. In the year 1994, what is the difference between the Rent(as % of GDP) in Nigeria and Rent(as % of GDP) in Romania?
Ensure brevity in your answer.  -1.43. In the year 1995, what is the difference between the Rent(as % of GDP) in High income and Rent(as % of GDP) in Latin America(developing only)?
Make the answer very short. 0.11. In the year 1995, what is the difference between the Rent(as % of GDP) of High income and Rent(as % of GDP) of Nigeria?
Offer a terse response. -0.81. In the year 1995, what is the difference between the Rent(as % of GDP) in High income and Rent(as % of GDP) in Romania?
Ensure brevity in your answer.  -2.34. In the year 1995, what is the difference between the Rent(as % of GDP) in Latin America(developing only) and Rent(as % of GDP) in Nigeria?
Keep it short and to the point. -0.91. In the year 1995, what is the difference between the Rent(as % of GDP) in Latin America(developing only) and Rent(as % of GDP) in Romania?
Offer a very short reply. -2.45. In the year 1995, what is the difference between the Rent(as % of GDP) in Nigeria and Rent(as % of GDP) in Romania?
Offer a terse response. -1.54. What is the ratio of the Rent(as % of GDP) of High income in 1988 to that in 1989?
Keep it short and to the point. 0.71. What is the ratio of the Rent(as % of GDP) in Latin America(developing only) in 1988 to that in 1989?
Your answer should be compact. 1.42. What is the ratio of the Rent(as % of GDP) in Nigeria in 1988 to that in 1989?
Provide a short and direct response. 0.99. What is the ratio of the Rent(as % of GDP) of Romania in 1988 to that in 1989?
Your answer should be compact. 1.29. What is the ratio of the Rent(as % of GDP) in High income in 1988 to that in 1990?
Offer a very short reply. 0.5. What is the ratio of the Rent(as % of GDP) of Latin America(developing only) in 1988 to that in 1990?
Provide a succinct answer. 1.09. What is the ratio of the Rent(as % of GDP) of Nigeria in 1988 to that in 1990?
Provide a succinct answer. 1.01. What is the ratio of the Rent(as % of GDP) of Romania in 1988 to that in 1990?
Offer a terse response. 0.9. What is the ratio of the Rent(as % of GDP) in High income in 1988 to that in 1991?
Your answer should be very brief. 0.51. What is the ratio of the Rent(as % of GDP) in Latin America(developing only) in 1988 to that in 1991?
Offer a very short reply. 1.27. What is the ratio of the Rent(as % of GDP) in Nigeria in 1988 to that in 1991?
Provide a succinct answer. 0.73. What is the ratio of the Rent(as % of GDP) in Romania in 1988 to that in 1991?
Provide a succinct answer. 0.77. What is the ratio of the Rent(as % of GDP) of High income in 1988 to that in 1992?
Your answer should be very brief. 0.65. What is the ratio of the Rent(as % of GDP) in Latin America(developing only) in 1988 to that in 1992?
Offer a terse response. 1.32. What is the ratio of the Rent(as % of GDP) in Nigeria in 1988 to that in 1992?
Your answer should be compact. 0.82. What is the ratio of the Rent(as % of GDP) of Romania in 1988 to that in 1992?
Your answer should be compact. 0.86. What is the ratio of the Rent(as % of GDP) of High income in 1988 to that in 1993?
Your answer should be very brief. 0.5. What is the ratio of the Rent(as % of GDP) of Latin America(developing only) in 1988 to that in 1993?
Offer a very short reply. 1.22. What is the ratio of the Rent(as % of GDP) in Nigeria in 1988 to that in 1993?
Your response must be concise. 0.34. What is the ratio of the Rent(as % of GDP) in Romania in 1988 to that in 1993?
Provide a short and direct response. 0.79. What is the ratio of the Rent(as % of GDP) in High income in 1988 to that in 1994?
Provide a succinct answer. 0.6. What is the ratio of the Rent(as % of GDP) in Latin America(developing only) in 1988 to that in 1994?
Your answer should be compact. 1.54. What is the ratio of the Rent(as % of GDP) of Nigeria in 1988 to that in 1994?
Offer a terse response. 0.45. What is the ratio of the Rent(as % of GDP) in Romania in 1988 to that in 1994?
Make the answer very short. 1.12. What is the ratio of the Rent(as % of GDP) in High income in 1988 to that in 1995?
Keep it short and to the point. 0.64. What is the ratio of the Rent(as % of GDP) of Latin America(developing only) in 1988 to that in 1995?
Offer a very short reply. 1.58. What is the ratio of the Rent(as % of GDP) in Nigeria in 1988 to that in 1995?
Keep it short and to the point. 0.71. What is the ratio of the Rent(as % of GDP) in Romania in 1988 to that in 1995?
Offer a terse response. 1.34. What is the ratio of the Rent(as % of GDP) of High income in 1989 to that in 1990?
Your answer should be compact. 0.71. What is the ratio of the Rent(as % of GDP) in Latin America(developing only) in 1989 to that in 1990?
Your response must be concise. 0.77. What is the ratio of the Rent(as % of GDP) of Nigeria in 1989 to that in 1990?
Keep it short and to the point. 1.02. What is the ratio of the Rent(as % of GDP) of Romania in 1989 to that in 1990?
Ensure brevity in your answer.  0.7. What is the ratio of the Rent(as % of GDP) in High income in 1989 to that in 1991?
Give a very brief answer. 0.73. What is the ratio of the Rent(as % of GDP) in Latin America(developing only) in 1989 to that in 1991?
Make the answer very short. 0.9. What is the ratio of the Rent(as % of GDP) of Nigeria in 1989 to that in 1991?
Make the answer very short. 0.73. What is the ratio of the Rent(as % of GDP) in Romania in 1989 to that in 1991?
Your answer should be compact. 0.6. What is the ratio of the Rent(as % of GDP) of High income in 1989 to that in 1992?
Your answer should be compact. 0.92. What is the ratio of the Rent(as % of GDP) in Latin America(developing only) in 1989 to that in 1992?
Give a very brief answer. 0.93. What is the ratio of the Rent(as % of GDP) in Nigeria in 1989 to that in 1992?
Give a very brief answer. 0.83. What is the ratio of the Rent(as % of GDP) of Romania in 1989 to that in 1992?
Ensure brevity in your answer.  0.67. What is the ratio of the Rent(as % of GDP) in High income in 1989 to that in 1993?
Make the answer very short. 0.7. What is the ratio of the Rent(as % of GDP) in Latin America(developing only) in 1989 to that in 1993?
Keep it short and to the point. 0.86. What is the ratio of the Rent(as % of GDP) of Nigeria in 1989 to that in 1993?
Provide a succinct answer. 0.35. What is the ratio of the Rent(as % of GDP) of Romania in 1989 to that in 1993?
Provide a short and direct response. 0.61. What is the ratio of the Rent(as % of GDP) in High income in 1989 to that in 1994?
Provide a succinct answer. 0.85. What is the ratio of the Rent(as % of GDP) in Latin America(developing only) in 1989 to that in 1994?
Make the answer very short. 1.08. What is the ratio of the Rent(as % of GDP) of Nigeria in 1989 to that in 1994?
Make the answer very short. 0.46. What is the ratio of the Rent(as % of GDP) of Romania in 1989 to that in 1994?
Make the answer very short. 0.87. What is the ratio of the Rent(as % of GDP) in High income in 1989 to that in 1995?
Your response must be concise. 0.91. What is the ratio of the Rent(as % of GDP) in Latin America(developing only) in 1989 to that in 1995?
Make the answer very short. 1.12. What is the ratio of the Rent(as % of GDP) in Nigeria in 1989 to that in 1995?
Provide a succinct answer. 0.72. What is the ratio of the Rent(as % of GDP) in Romania in 1989 to that in 1995?
Your answer should be compact. 1.04. What is the ratio of the Rent(as % of GDP) in High income in 1990 to that in 1991?
Provide a short and direct response. 1.02. What is the ratio of the Rent(as % of GDP) of Latin America(developing only) in 1990 to that in 1991?
Your answer should be compact. 1.16. What is the ratio of the Rent(as % of GDP) of Nigeria in 1990 to that in 1991?
Your answer should be compact. 0.72. What is the ratio of the Rent(as % of GDP) of Romania in 1990 to that in 1991?
Your response must be concise. 0.86. What is the ratio of the Rent(as % of GDP) of High income in 1990 to that in 1992?
Your response must be concise. 1.29. What is the ratio of the Rent(as % of GDP) in Latin America(developing only) in 1990 to that in 1992?
Ensure brevity in your answer.  1.21. What is the ratio of the Rent(as % of GDP) of Nigeria in 1990 to that in 1992?
Provide a succinct answer. 0.82. What is the ratio of the Rent(as % of GDP) in Romania in 1990 to that in 1992?
Provide a succinct answer. 0.95. What is the ratio of the Rent(as % of GDP) in High income in 1990 to that in 1993?
Your answer should be very brief. 0.99. What is the ratio of the Rent(as % of GDP) in Latin America(developing only) in 1990 to that in 1993?
Offer a terse response. 1.12. What is the ratio of the Rent(as % of GDP) of Nigeria in 1990 to that in 1993?
Your answer should be compact. 0.34. What is the ratio of the Rent(as % of GDP) of Romania in 1990 to that in 1993?
Your answer should be very brief. 0.87. What is the ratio of the Rent(as % of GDP) of High income in 1990 to that in 1994?
Ensure brevity in your answer.  1.2. What is the ratio of the Rent(as % of GDP) of Latin America(developing only) in 1990 to that in 1994?
Offer a very short reply. 1.41. What is the ratio of the Rent(as % of GDP) of Nigeria in 1990 to that in 1994?
Keep it short and to the point. 0.45. What is the ratio of the Rent(as % of GDP) of Romania in 1990 to that in 1994?
Provide a short and direct response. 1.25. What is the ratio of the Rent(as % of GDP) in High income in 1990 to that in 1995?
Your response must be concise. 1.28. What is the ratio of the Rent(as % of GDP) of Latin America(developing only) in 1990 to that in 1995?
Make the answer very short. 1.45. What is the ratio of the Rent(as % of GDP) of Nigeria in 1990 to that in 1995?
Your response must be concise. 0.71. What is the ratio of the Rent(as % of GDP) in Romania in 1990 to that in 1995?
Offer a very short reply. 1.49. What is the ratio of the Rent(as % of GDP) in High income in 1991 to that in 1992?
Provide a short and direct response. 1.26. What is the ratio of the Rent(as % of GDP) in Latin America(developing only) in 1991 to that in 1992?
Your answer should be compact. 1.04. What is the ratio of the Rent(as % of GDP) in Nigeria in 1991 to that in 1992?
Offer a terse response. 1.14. What is the ratio of the Rent(as % of GDP) in Romania in 1991 to that in 1992?
Your answer should be compact. 1.11. What is the ratio of the Rent(as % of GDP) in High income in 1991 to that in 1993?
Offer a very short reply. 0.97. What is the ratio of the Rent(as % of GDP) of Latin America(developing only) in 1991 to that in 1993?
Offer a very short reply. 0.97. What is the ratio of the Rent(as % of GDP) of Nigeria in 1991 to that in 1993?
Give a very brief answer. 0.47. What is the ratio of the Rent(as % of GDP) in Romania in 1991 to that in 1993?
Ensure brevity in your answer.  1.02. What is the ratio of the Rent(as % of GDP) in High income in 1991 to that in 1994?
Offer a terse response. 1.18. What is the ratio of the Rent(as % of GDP) in Latin America(developing only) in 1991 to that in 1994?
Provide a succinct answer. 1.21. What is the ratio of the Rent(as % of GDP) of Nigeria in 1991 to that in 1994?
Provide a short and direct response. 0.62. What is the ratio of the Rent(as % of GDP) in Romania in 1991 to that in 1994?
Your answer should be compact. 1.45. What is the ratio of the Rent(as % of GDP) of High income in 1991 to that in 1995?
Make the answer very short. 1.25. What is the ratio of the Rent(as % of GDP) in Latin America(developing only) in 1991 to that in 1995?
Your answer should be compact. 1.25. What is the ratio of the Rent(as % of GDP) of Nigeria in 1991 to that in 1995?
Keep it short and to the point. 0.98. What is the ratio of the Rent(as % of GDP) of Romania in 1991 to that in 1995?
Ensure brevity in your answer.  1.74. What is the ratio of the Rent(as % of GDP) of High income in 1992 to that in 1993?
Your answer should be compact. 0.77. What is the ratio of the Rent(as % of GDP) in Latin America(developing only) in 1992 to that in 1993?
Your answer should be compact. 0.93. What is the ratio of the Rent(as % of GDP) in Nigeria in 1992 to that in 1993?
Ensure brevity in your answer.  0.42. What is the ratio of the Rent(as % of GDP) in Romania in 1992 to that in 1993?
Give a very brief answer. 0.91. What is the ratio of the Rent(as % of GDP) of High income in 1992 to that in 1994?
Give a very brief answer. 0.93. What is the ratio of the Rent(as % of GDP) in Latin America(developing only) in 1992 to that in 1994?
Offer a very short reply. 1.17. What is the ratio of the Rent(as % of GDP) in Nigeria in 1992 to that in 1994?
Provide a succinct answer. 0.55. What is the ratio of the Rent(as % of GDP) of Romania in 1992 to that in 1994?
Give a very brief answer. 1.31. What is the ratio of the Rent(as % of GDP) of Latin America(developing only) in 1992 to that in 1995?
Offer a terse response. 1.2. What is the ratio of the Rent(as % of GDP) in Nigeria in 1992 to that in 1995?
Give a very brief answer. 0.86. What is the ratio of the Rent(as % of GDP) in Romania in 1992 to that in 1995?
Make the answer very short. 1.56. What is the ratio of the Rent(as % of GDP) in High income in 1993 to that in 1994?
Offer a terse response. 1.21. What is the ratio of the Rent(as % of GDP) of Latin America(developing only) in 1993 to that in 1994?
Provide a short and direct response. 1.25. What is the ratio of the Rent(as % of GDP) of Nigeria in 1993 to that in 1994?
Make the answer very short. 1.32. What is the ratio of the Rent(as % of GDP) of Romania in 1993 to that in 1994?
Provide a succinct answer. 1.43. What is the ratio of the Rent(as % of GDP) of High income in 1993 to that in 1995?
Provide a succinct answer. 1.29. What is the ratio of the Rent(as % of GDP) of Latin America(developing only) in 1993 to that in 1995?
Your response must be concise. 1.29. What is the ratio of the Rent(as % of GDP) in Nigeria in 1993 to that in 1995?
Provide a succinct answer. 2.08. What is the ratio of the Rent(as % of GDP) in Romania in 1993 to that in 1995?
Your answer should be very brief. 1.71. What is the ratio of the Rent(as % of GDP) in High income in 1994 to that in 1995?
Offer a very short reply. 1.07. What is the ratio of the Rent(as % of GDP) in Latin America(developing only) in 1994 to that in 1995?
Make the answer very short. 1.03. What is the ratio of the Rent(as % of GDP) in Nigeria in 1994 to that in 1995?
Provide a succinct answer. 1.58. What is the ratio of the Rent(as % of GDP) of Romania in 1994 to that in 1995?
Your answer should be very brief. 1.2. What is the difference between the highest and the second highest Rent(as % of GDP) in High income?
Keep it short and to the point. 0. What is the difference between the highest and the second highest Rent(as % of GDP) of Latin America(developing only)?
Make the answer very short. 0.02. What is the difference between the highest and the second highest Rent(as % of GDP) of Nigeria?
Make the answer very short. 0.54. What is the difference between the highest and the second highest Rent(as % of GDP) in Romania?
Provide a short and direct response. 0.07. What is the difference between the highest and the lowest Rent(as % of GDP) in High income?
Provide a short and direct response. 0.17. What is the difference between the highest and the lowest Rent(as % of GDP) in Latin America(developing only)?
Provide a short and direct response. 0.09. What is the difference between the highest and the lowest Rent(as % of GDP) of Nigeria?
Your answer should be compact. 1.47. What is the difference between the highest and the lowest Rent(as % of GDP) of Romania?
Ensure brevity in your answer.  1.92. 